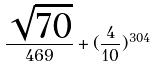<formula> <loc_0><loc_0><loc_500><loc_500>\frac { \sqrt { 7 0 } } { 4 6 9 } + ( \frac { 4 } { 1 0 } ) ^ { 3 0 4 }</formula> 